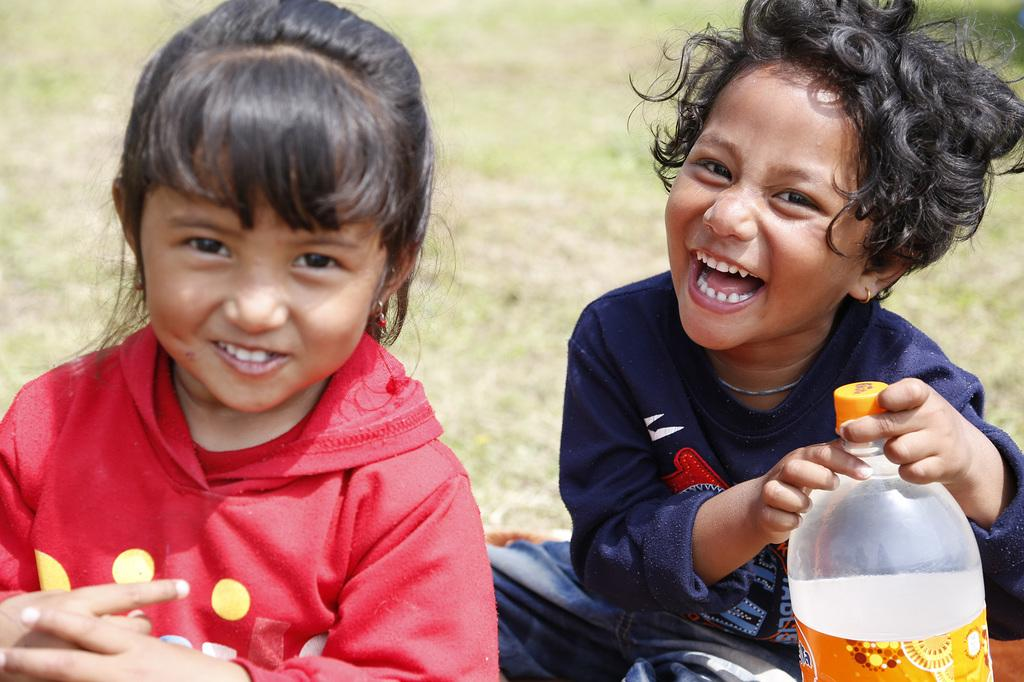How many girls are in the image? There are two girls in the image. What are the girls doing in the image? The girls are sitting on the ground. What is one of the girls holding? One of the girls is holding a water bottle. What is the facial expression of the girls in the image? Both girls are smiling. What can be seen in the background of the image? There is a land visible in the background of the image. How many cards are being pointed at by the girls in the image? There are no cards present in the image, and the girls are not pointing at anything. How many cats can be seen interacting with the girls in the image? There are no cats present in the image; it only features the two girls. 